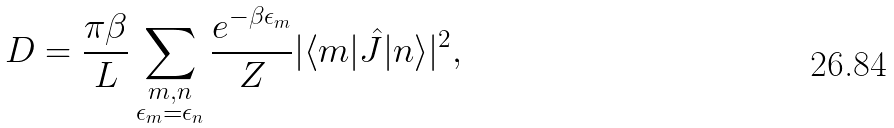Convert formula to latex. <formula><loc_0><loc_0><loc_500><loc_500>D = \frac { \pi \beta } { L } \sum _ { \substack { m , n \\ \epsilon _ { m } = \epsilon _ { n } } } \frac { e ^ { - \beta \epsilon _ { m } } } { Z } | \langle m | \hat { J } | n \rangle | ^ { 2 } ,</formula> 